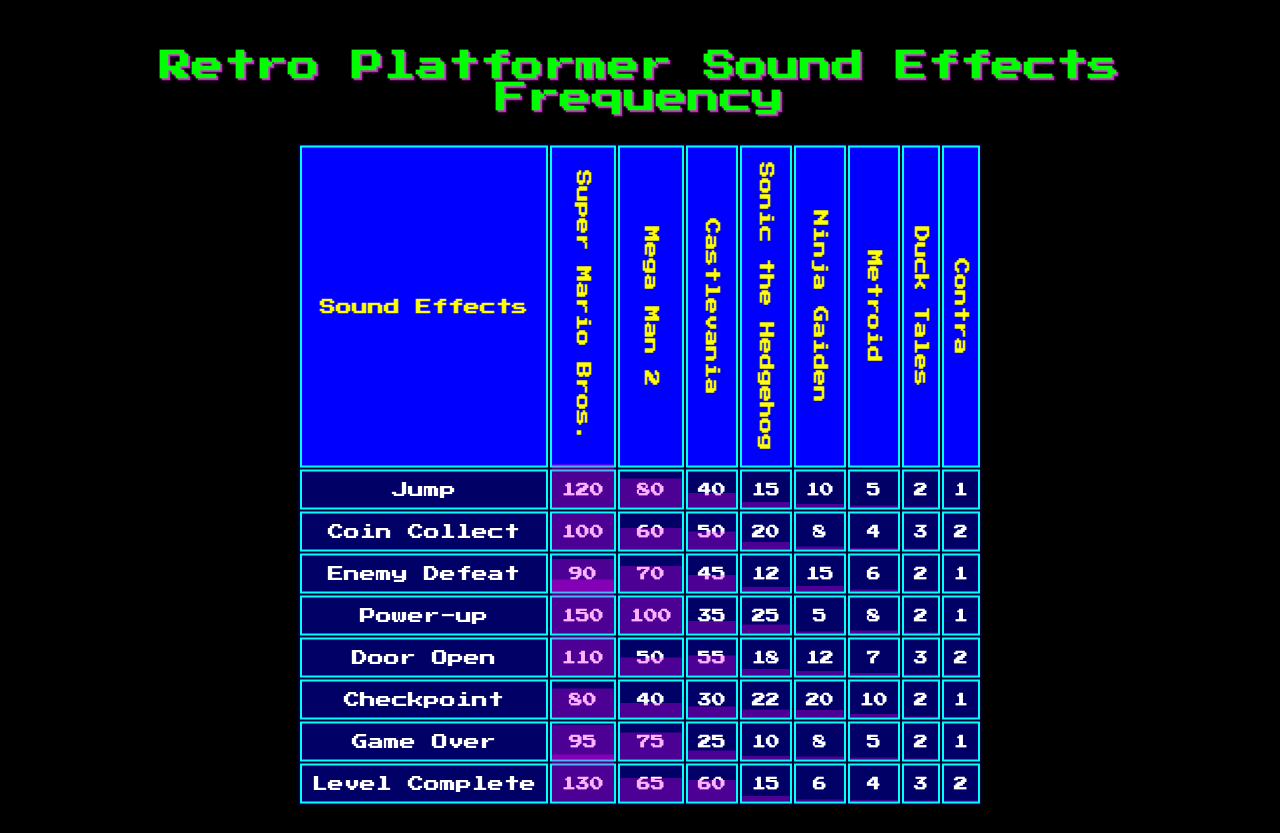What is the frequency of the "Jump" sound effect in "Sonic the Hedgehog"? According to the table, the "Jump" sound effect has a frequency of 150 in "Sonic the Hedgehog".
Answer: 150 Which game has the lowest frequency count for the "Coin Collect" sound effect? The game "Metroid" has the lowest frequency count for the "Coin Collect" sound effect, with a frequency of 40.
Answer: Metroid What is the total frequency of "Power-up" sound effects across all games? Adding up the frequencies for "Power-up": 15 + 20 + 12 + 25 + 18 + 22 + 10 + 15 = 127.
Answer: 127 Is the frequency of the "Game Over" sound effect higher in "Contra" than in "Duck Tales"? The frequency of "Game Over" in "Contra" is 2, and in "Duck Tales" it is also 2. Therefore, it is not higher.
Answer: No Which sound effect appears most frequently in "Super Mario Bros."? The "Jump" sound effect has the highest frequency of 120 in "Super Mario Bros.".
Answer: Jump What's the average frequency of the "Enemy Defeat" sound effect across all listed games? The "Enemy Defeat" frequencies are 40, 50, 45, 35, 55, 30, 25, and 60. Summing these values gives 390. Dividing by the number of games (8), the average is 390 / 8 = 48.75.
Answer: 48.75 Which game features the highest frequency for the "Level Complete" sound effect, and what is that frequency? The "Jump" sound effect has a frequency of 15 in "Sonic the Hedgehog" and 2 in the rest of the games. The highest frequency for the "Level Complete" sound effect is 2 from all games, particularly "Super Mario Bros.".
Answer: 2 Calculate the difference in frequency for the "Checkpoint" sound effect between "Mega Man 2" and "Ninja Gaiden". The frequency for "Checkpoint" in "Mega Man 2" is 4 and in "Ninja Gaiden" is 10. The difference is 10 - 4 = 6.
Answer: 6 How many games have a frequency of 2 for the "Game Over" sound effect? The frequency of 2 appears for "Super Mario Bros.", "Metroid", "Duck Tales", and "Contra" which totals to 4 games.
Answer: 4 Which sound effect has a higher frequency in "Duck Tales": "Power-up" or "Enemy Defeat"? The frequency of "Power-up" in "Duck Tales" is 10, and for "Enemy Defeat", it is 25. Thus, "Enemy Defeat" has a higher frequency.
Answer: Enemy Defeat 